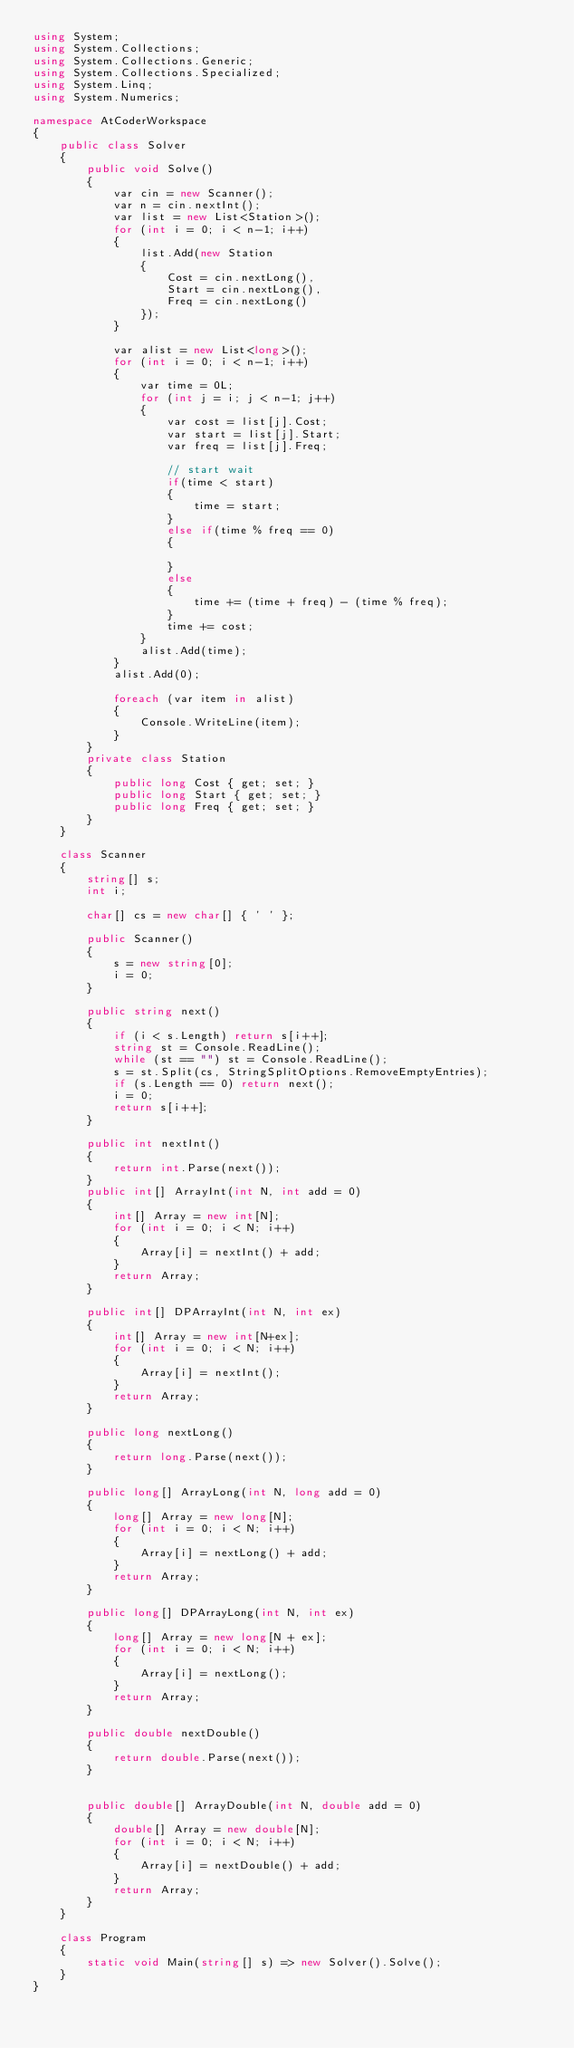Convert code to text. <code><loc_0><loc_0><loc_500><loc_500><_C#_>using System;
using System.Collections;
using System.Collections.Generic;
using System.Collections.Specialized;
using System.Linq;
using System.Numerics;

namespace AtCoderWorkspace
{
    public class Solver
    {
        public void Solve()
        {
            var cin = new Scanner();
            var n = cin.nextInt();
            var list = new List<Station>();
            for (int i = 0; i < n-1; i++)
            {
                list.Add(new Station
                {
                    Cost = cin.nextLong(),
                    Start = cin.nextLong(),
                    Freq = cin.nextLong()
                });
            }

            var alist = new List<long>();
            for (int i = 0; i < n-1; i++)
            {
                var time = 0L;
                for (int j = i; j < n-1; j++)
                {
                    var cost = list[j].Cost;
                    var start = list[j].Start;
                    var freq = list[j].Freq;

                    // start wait
                    if(time < start)
                    {
                        time = start;
                    }
                    else if(time % freq == 0)
                    {

                    }
                    else
                    {
                        time += (time + freq) - (time % freq);
                    }
                    time += cost;
                }
                alist.Add(time);
            }
            alist.Add(0);

            foreach (var item in alist)
            {
                Console.WriteLine(item);
            }            
        }
        private class Station
        {
            public long Cost { get; set; }
            public long Start { get; set; }
            public long Freq { get; set; }
        }
    }

    class Scanner
    {
        string[] s;
        int i;

        char[] cs = new char[] { ' ' };

        public Scanner()
        {
            s = new string[0];
            i = 0;
        }

        public string next()
        {
            if (i < s.Length) return s[i++];
            string st = Console.ReadLine();
            while (st == "") st = Console.ReadLine();
            s = st.Split(cs, StringSplitOptions.RemoveEmptyEntries);
            if (s.Length == 0) return next();
            i = 0;
            return s[i++];
        }

        public int nextInt()
        {
            return int.Parse(next());
        }
        public int[] ArrayInt(int N, int add = 0)
        {
            int[] Array = new int[N];
            for (int i = 0; i < N; i++)
            {
                Array[i] = nextInt() + add;
            }
            return Array;
        }

        public int[] DPArrayInt(int N, int ex)
        {
            int[] Array = new int[N+ex];
            for (int i = 0; i < N; i++)
            {
                Array[i] = nextInt();
            }
            return Array;
        }

        public long nextLong()
        {
            return long.Parse(next());
        }

        public long[] ArrayLong(int N, long add = 0)
        {
            long[] Array = new long[N];
            for (int i = 0; i < N; i++)
            {
                Array[i] = nextLong() + add;
            }
            return Array;
        }

        public long[] DPArrayLong(int N, int ex)
        {
            long[] Array = new long[N + ex];
            for (int i = 0; i < N; i++)
            {
                Array[i] = nextLong();
            }
            return Array;
        }

        public double nextDouble()
        {
            return double.Parse(next());
        }


        public double[] ArrayDouble(int N, double add = 0)
        {
            double[] Array = new double[N];
            for (int i = 0; i < N; i++)
            {
                Array[i] = nextDouble() + add;
            }
            return Array;
        }
    }   

    class Program
    {
        static void Main(string[] s) => new Solver().Solve();
    }
}
</code> 